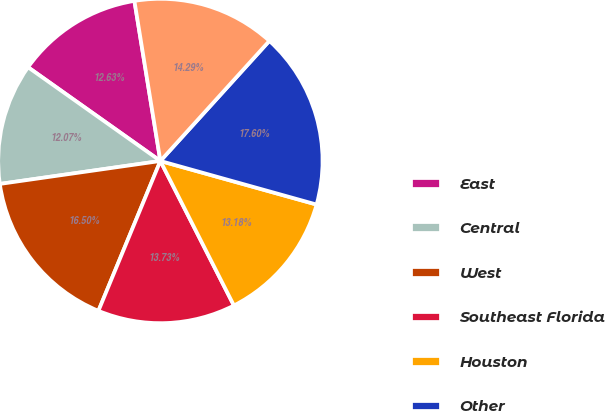Convert chart. <chart><loc_0><loc_0><loc_500><loc_500><pie_chart><fcel>East<fcel>Central<fcel>West<fcel>Southeast Florida<fcel>Houston<fcel>Other<fcel>Total<nl><fcel>12.63%<fcel>12.07%<fcel>16.5%<fcel>13.73%<fcel>13.18%<fcel>17.6%<fcel>14.29%<nl></chart> 